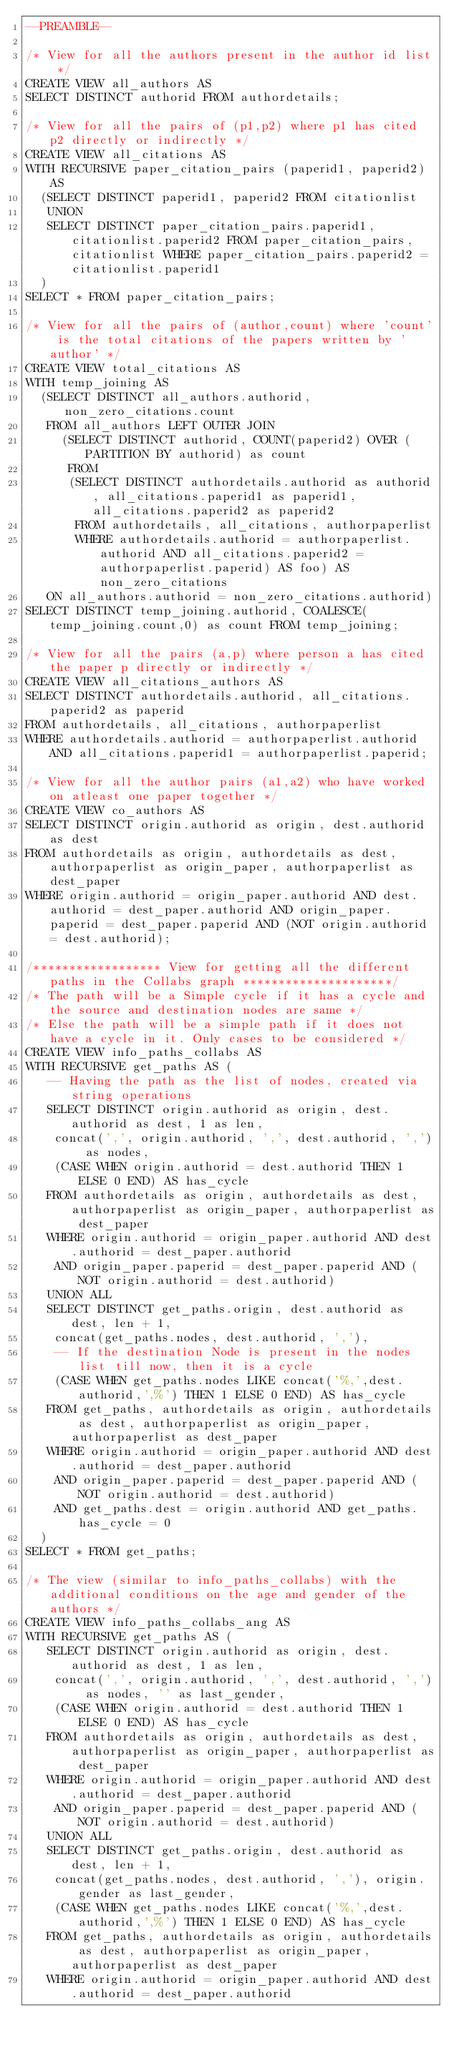Convert code to text. <code><loc_0><loc_0><loc_500><loc_500><_SQL_>--PREAMBLE--

/* View for all the authors present in the author id list */
CREATE VIEW all_authors AS 
SELECT DISTINCT authorid FROM authordetails;

/* View for all the pairs of (p1,p2) where p1 has cited p2 directly or indirectly */
CREATE VIEW all_citations AS
WITH RECURSIVE paper_citation_pairs (paperid1, paperid2) AS 
	(SELECT DISTINCT paperid1, paperid2 FROM citationlist
	 UNION 
	 SELECT DISTINCT paper_citation_pairs.paperid1, citationlist.paperid2 FROM paper_citation_pairs, citationlist WHERE paper_citation_pairs.paperid2 = citationlist.paperid1
	)
SELECT * FROM paper_citation_pairs;

/* View for all the pairs of (author,count) where 'count' is the total citations of the papers written by 'author' */
CREATE VIEW total_citations AS
WITH temp_joining AS
	(SELECT DISTINCT all_authors.authorid, non_zero_citations.count
	 FROM all_authors LEFT OUTER JOIN 	 
		 (SELECT DISTINCT authorid, COUNT(paperid2) OVER (PARTITION BY authorid) as count
		  FROM
			(SELECT DISTINCT authordetails.authorid as authorid, all_citations.paperid1 as paperid1, all_citations.paperid2 as paperid2
			 FROM authordetails, all_citations, authorpaperlist
			 WHERE authordetails.authorid = authorpaperlist.authorid AND all_citations.paperid2 = authorpaperlist.paperid) AS foo) AS non_zero_citations
	 ON all_authors.authorid = non_zero_citations.authorid)
SELECT DISTINCT temp_joining.authorid, COALESCE(temp_joining.count,0) as count FROM temp_joining;

/* View for all the pairs (a,p) where person a has cited the paper p directly or indirectly */
CREATE VIEW all_citations_authors AS
SELECT DISTINCT authordetails.authorid, all_citations.paperid2 as paperid
FROM authordetails, all_citations, authorpaperlist
WHERE authordetails.authorid = authorpaperlist.authorid AND all_citations.paperid1 = authorpaperlist.paperid;

/* View for all the author pairs (a1,a2) who have worked on atleast one paper together */
CREATE VIEW co_authors AS
SELECT DISTINCT origin.authorid as origin, dest.authorid as dest
FROM authordetails as origin, authordetails as dest, authorpaperlist as origin_paper, authorpaperlist as dest_paper
WHERE origin.authorid = origin_paper.authorid AND dest.authorid = dest_paper.authorid AND origin_paper.paperid = dest_paper.paperid AND (NOT origin.authorid = dest.authorid);

/****************** View for getting all the different paths in the Collabs graph *********************/
/* The path will be a Simple cycle if it has a cycle and the source and destination nodes are same */
/* Else the path will be a simple path if it does not have a cycle in it. Only cases to be considered */
CREATE VIEW info_paths_collabs AS 
WITH RECURSIVE get_paths AS (
	 -- Having the path as the list of nodes, created via string operations 
	 SELECT DISTINCT origin.authorid as origin, dest.authorid as dest, 1 as len, 
	 	concat(',', origin.authorid, ',', dest.authorid, ',') as nodes,
	 	(CASE WHEN origin.authorid = dest.authorid THEN 1 ELSE 0 END) AS has_cycle
	 FROM authordetails as origin, authordetails as dest, authorpaperlist as origin_paper, authorpaperlist as dest_paper
	 WHERE origin.authorid = origin_paper.authorid AND dest.authorid = dest_paper.authorid
	 	AND origin_paper.paperid = dest_paper.paperid AND (NOT origin.authorid = dest.authorid)
	 UNION ALL
	 SELECT DISTINCT get_paths.origin, dest.authorid as dest, len + 1,
	 	concat(get_paths.nodes, dest.authorid, ','),
	 	-- If the destination Node is present in the nodes list till now, then it is a cycle
	 	(CASE WHEN get_paths.nodes LIKE concat('%,',dest.authorid,',%') THEN 1 ELSE 0 END) AS has_cycle
	 FROM get_paths, authordetails as origin, authordetails as dest, authorpaperlist as origin_paper, authorpaperlist as dest_paper
	 WHERE origin.authorid = origin_paper.authorid AND dest.authorid = dest_paper.authorid
	 	AND origin_paper.paperid = dest_paper.paperid AND (NOT origin.authorid = dest.authorid)
	 	AND get_paths.dest = origin.authorid AND get_paths.has_cycle = 0
	)
SELECT * FROM get_paths;

/* The view (similar to info_paths_collabs) with the additional conditions on the age and gender of the authors */
CREATE VIEW info_paths_collabs_ang AS 
WITH RECURSIVE get_paths AS (
	 SELECT DISTINCT origin.authorid as origin, dest.authorid as dest, 1 as len, 
	 	concat(',', origin.authorid, ',', dest.authorid, ',') as nodes, '' as last_gender,
	 	(CASE WHEN origin.authorid = dest.authorid THEN 1 ELSE 0 END) AS has_cycle
	 FROM authordetails as origin, authordetails as dest, authorpaperlist as origin_paper, authorpaperlist as dest_paper
	 WHERE origin.authorid = origin_paper.authorid AND dest.authorid = dest_paper.authorid
	 	AND origin_paper.paperid = dest_paper.paperid AND (NOT origin.authorid = dest.authorid)
	 UNION ALL
	 SELECT DISTINCT get_paths.origin, dest.authorid as dest, len + 1,
	 	concat(get_paths.nodes, dest.authorid, ','), origin.gender as last_gender,
	 	(CASE WHEN get_paths.nodes LIKE concat('%,',dest.authorid,',%') THEN 1 ELSE 0 END) AS has_cycle
	 FROM get_paths, authordetails as origin, authordetails as dest, authorpaperlist as origin_paper, authorpaperlist as dest_paper
	 WHERE origin.authorid = origin_paper.authorid AND dest.authorid = dest_paper.authorid</code> 